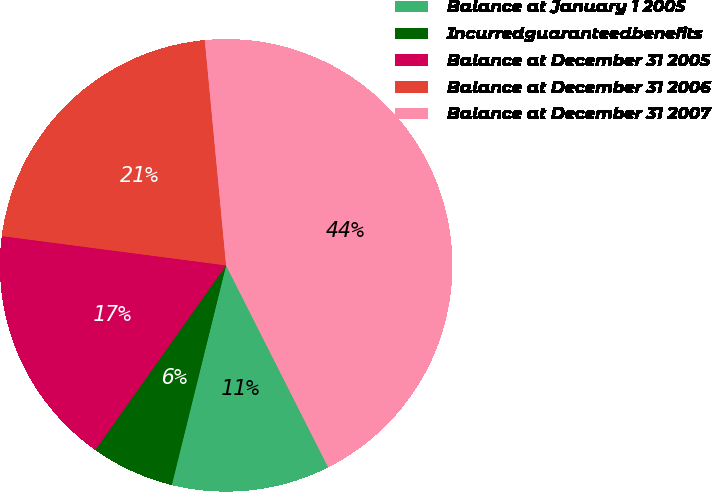<chart> <loc_0><loc_0><loc_500><loc_500><pie_chart><fcel>Balance at January 1 2005<fcel>Incurredguaranteedbenefits<fcel>Balance at December 31 2005<fcel>Balance at December 31 2006<fcel>Balance at December 31 2007<nl><fcel>11.31%<fcel>5.95%<fcel>17.26%<fcel>21.43%<fcel>44.05%<nl></chart> 